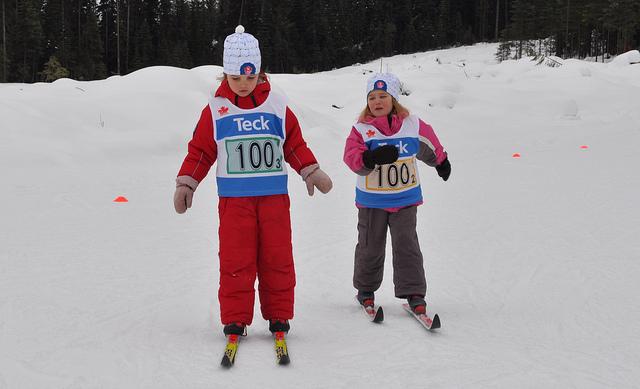What number is on the child?
Answer briefly. 100. How many people are wearing hats?
Write a very short answer. 2. What are the kids doing?
Give a very brief answer. Skiing. What are they wearing?
Short answer required. Snowsuits. What is the number on the vests?
Write a very short answer. 100. Do the people look tired?
Keep it brief. No. What color is the hat?
Quick response, please. White. 